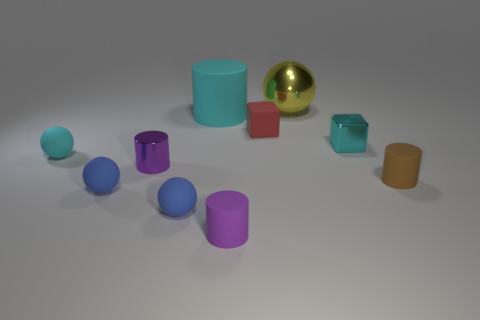How big is the purple cylinder that is in front of the small cylinder that is to the right of the tiny matte cylinder in front of the brown matte cylinder?
Keep it short and to the point. Small. There is another cylinder that is the same color as the metal cylinder; what is it made of?
Provide a succinct answer. Rubber. Are there any other things that have the same shape as the cyan metallic object?
Keep it short and to the point. Yes. What size is the cyan object that is left of the matte cylinder behind the tiny shiny block?
Offer a terse response. Small. How many small objects are either matte cylinders or gray matte balls?
Give a very brief answer. 2. Is the number of small rubber cylinders less than the number of brown cylinders?
Offer a very short reply. No. Is there any other thing that has the same size as the purple matte cylinder?
Offer a very short reply. Yes. Is the color of the large rubber object the same as the shiny cube?
Your response must be concise. Yes. Is the number of large yellow shiny spheres greater than the number of brown metallic balls?
Offer a terse response. Yes. What number of other things are there of the same color as the big rubber cylinder?
Your response must be concise. 2. 